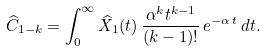<formula> <loc_0><loc_0><loc_500><loc_500>\widehat { C } _ { 1 - k } & = \int _ { 0 } ^ { \infty } \widehat { X } _ { 1 } ( t ) \, \frac { \alpha ^ { k } t ^ { k - 1 } } { ( k - 1 ) ! } \, e ^ { - \alpha \, t } \, d t . \\</formula> 